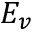Convert formula to latex. <formula><loc_0><loc_0><loc_500><loc_500>E _ { v }</formula> 